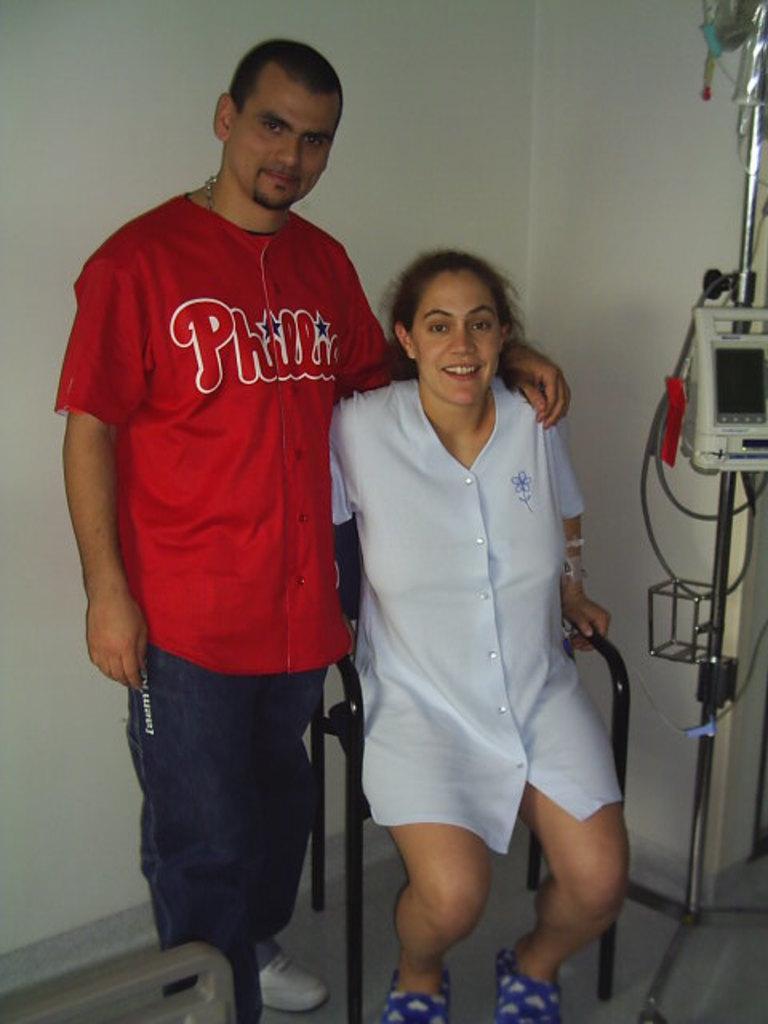Could you give a brief overview of what you see in this image? In this image I can see a person wearing red and black colored dress is standing and a woman wearing white colored dress is sitting on a chair. In the background I can see a machine to the metal rod and the white colored wall. 